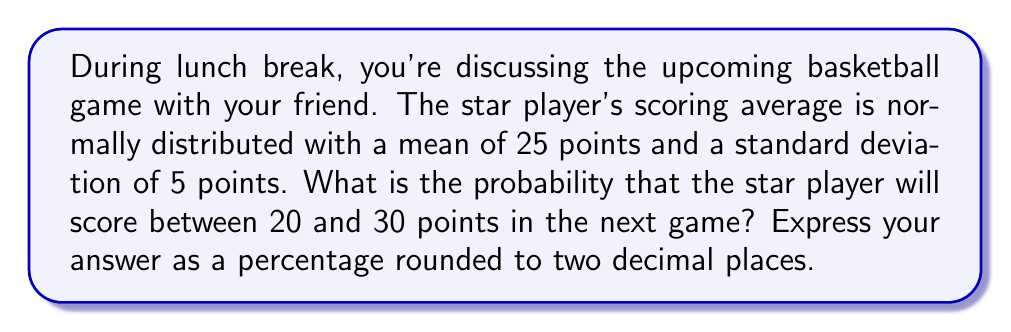Can you solve this math problem? Let's approach this step-by-step:

1) First, we need to standardize the given interval. The z-score formula is:

   $$ z = \frac{x - \mu}{\sigma} $$

   where $x$ is the value, $\mu$ is the mean, and $\sigma$ is the standard deviation.

2) For the lower bound (20 points):
   $$ z_1 = \frac{20 - 25}{5} = -1 $$

3) For the upper bound (30 points):
   $$ z_2 = \frac{30 - 25}{5} = 1 $$

4) Now, we need to find the probability between these z-scores:
   $$ P(-1 < Z < 1) $$

5) This is equivalent to:
   $$ P(Z < 1) - P(Z < -1) $$

6) Using a standard normal distribution table or calculator:
   $$ P(Z < 1) \approx 0.8413 $$
   $$ P(Z < -1) \approx 0.1587 $$

7) Therefore, the probability is:
   $$ 0.8413 - 0.1587 = 0.6826 $$

8) Converting to a percentage:
   $$ 0.6826 * 100 \approx 68.26\% $$
Answer: 68.26% 